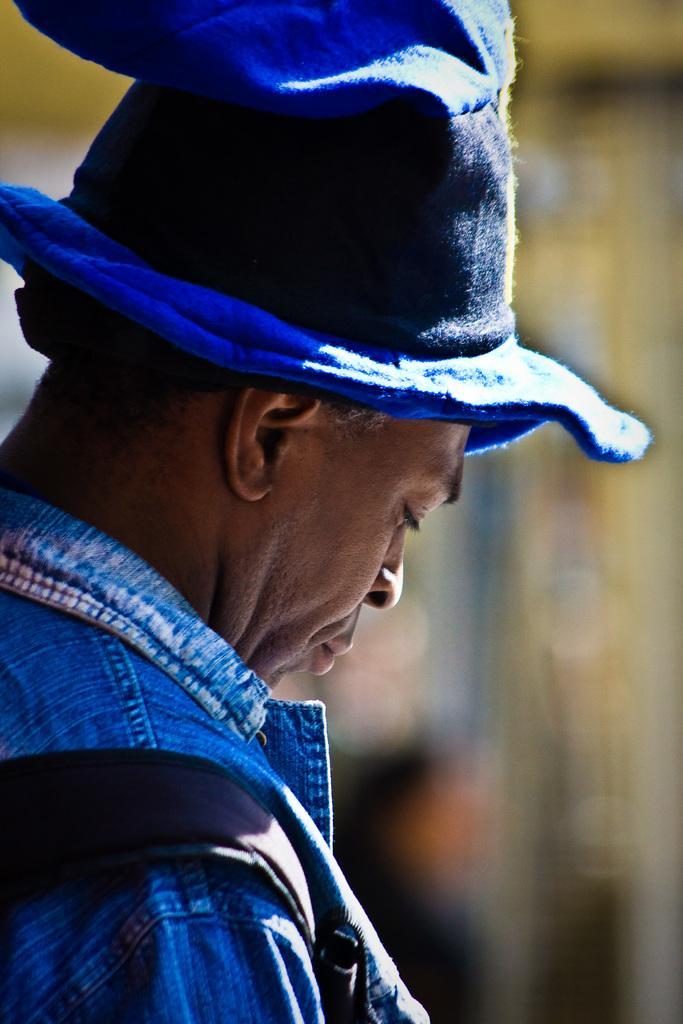Describe this image in one or two sentences. In this image, there is a person wearing clothes and hat. 